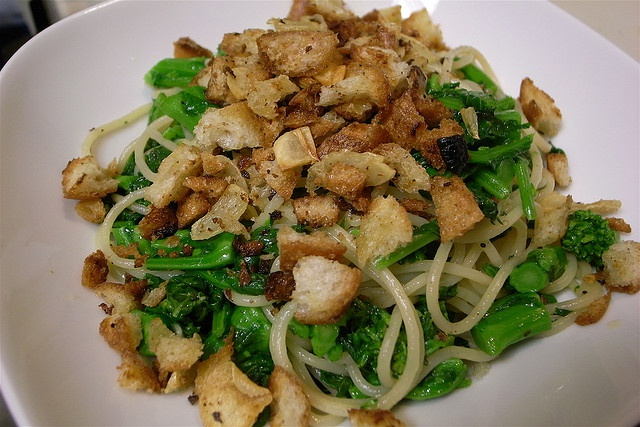Describe the objects in this image and their specific colors. I can see broccoli in gray, black, and darkgreen tones, broccoli in gray, darkgreen, black, and olive tones, broccoli in gray, darkgreen, and green tones, broccoli in gray, black, darkgreen, and olive tones, and broccoli in gray, black, darkgreen, and green tones in this image. 